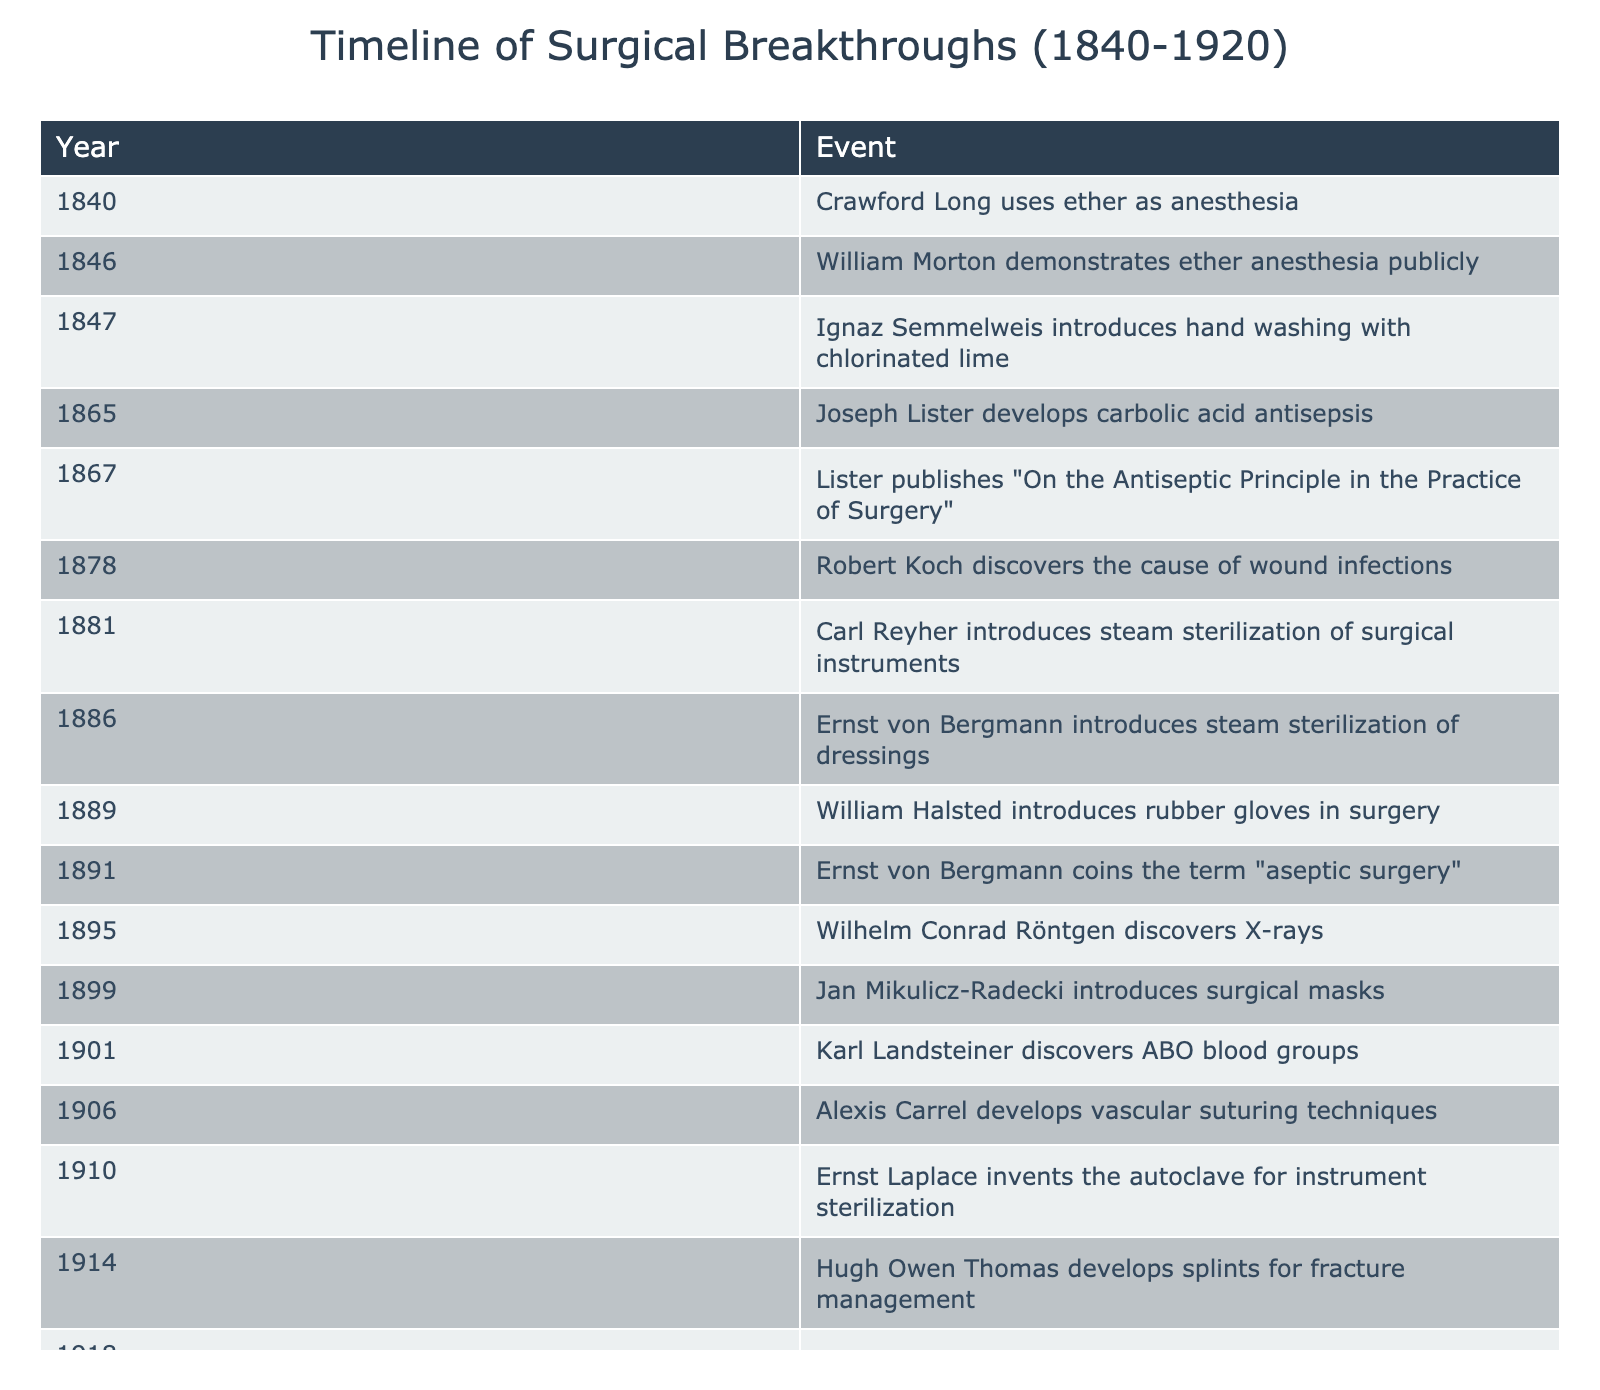What year did Joseph Lister develop carbolic acid antisepsis? The table indicates that Joseph Lister developed carbolic acid antisepsis in the year 1865.
Answer: 1865 How many years after the introduction of hand washing did Lister publish his work on antiseptic principles? Ignaz Semmelweis introduced hand washing in 1847, and Lister published his work in 1867. The difference between 1867 and 1847 is 20 years.
Answer: 20 years Was steam sterilization introduced before or after the introduction of rubber gloves in surgery? The table shows that Carl Reyher introduced steam sterilization in 1881 and William Halsted introduced rubber gloves in 1889. Therefore, steam sterilization was introduced before rubber gloves.
Answer: Before Which event occurred first: the discovery of X-rays or the introduction of surgical masks? The table lists the discovery of X-rays by Wilhelm Conrad Röntgen in 1895 and the introduction of surgical masks by Jan Mikulicz-Radecki in 1899. Since 1895 is earlier than 1899, X-rays were discovered first.
Answer: X-rays were discovered first How many events related to antiseptic and aseptic practices occurred between 1880 and 1900? By checking the dates in the table, the relevant events are: steam sterilization in 1881, rubber gloves in 1889, and surgical masks in 1899. Counting these, we find a total of 3 events.
Answer: 3 events List the two individuals who contributed to wound antisepsis in 1918. The table indicates that Alexis Carrel and Henry Dakin developed the Carrel-Dakin solution for wound antisepsis in 1918. Therefore, the individuals are Alexis Carrel and Henry Dakin.
Answer: Alexis Carrel and Henry Dakin What was the primary focus of Ernst von Bergmann's contributions listed in the table? Ernst von Bergmann is associated with two major contributions: the introduction of steam sterilization of dressings in 1886 and coining the term "aseptic surgery" in 1891. His primary focus was on sterilization and aseptic techniques in surgery.
Answer: Sterilization and aseptic techniques Which year saw the most significant number of innovations or discoveries listed, and how many were there? Scanning the table, the year 1867 stands out with the publication of Lister's work on antiseptic principle and is the only significant entry that year, thus having 1 event.
Answer: 1867, 1 event Did any advancements in surgical practices occur during World War I based on the table? The table shows an event in 1914 with Hugh Owen Thomas developing splints for fracture management, which can be associated with surgical advancements relevant to the war context.
Answer: Yes Which breakthrough was made by Karl Landsteiner, and what year did it happen? Karl Landsteiner discovered ABO blood groups in 1901, as indicated in the table.
Answer: ABO blood groups, 1901 Assuming a trend in the introduction of antiseptic techniques, predict how many breakthrough events are expected in the subsequent decade (1920-1930) based on the last years indicated in the table. While the table does indicate significant breakthroughs up to 1918, predicting future events requires additional information on trends or patterns in medical advancements that is not available from the current data. No prediction can be accurately made without further data.
Answer: Cannot predict 